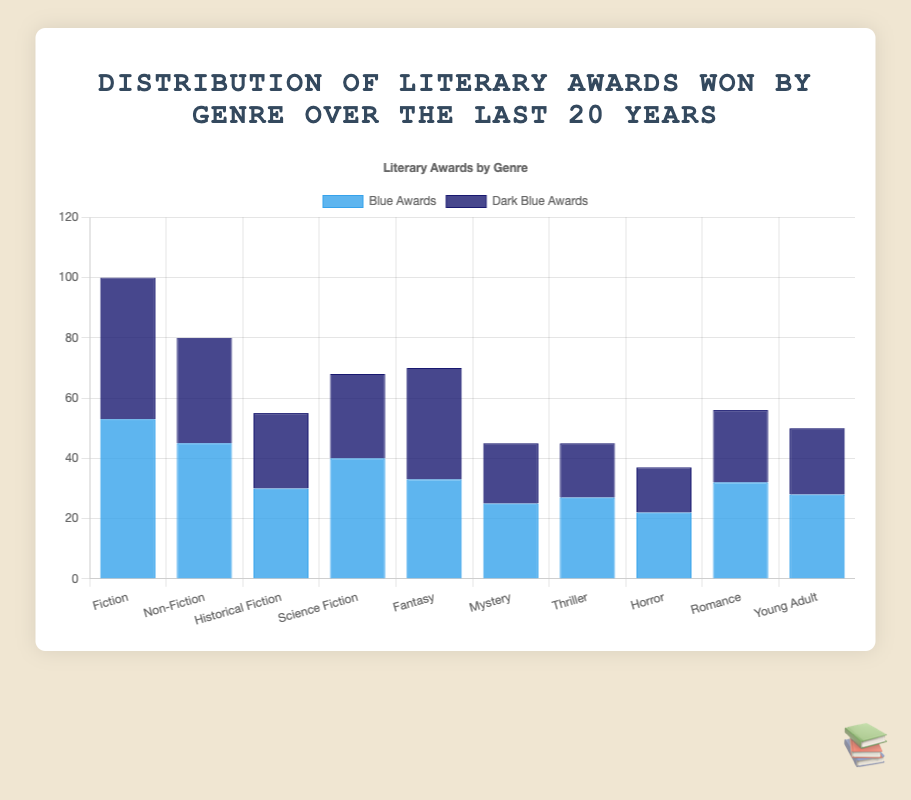Which genre has the highest total number of awards? To find the genre with the highest total number of awards, we need to sum the blue and dark blue awards for each genre and compare. Fiction: 53 + 47 = 100, Non-Fiction: 45 + 35 = 80, Historical Fiction: 30 + 25 = 55, Science Fiction: 40 + 28 = 68, Fantasy: 33 + 37 = 70, Mystery: 25 + 20 = 45, Thriller: 27 + 18 = 45, Horror: 22 + 15 = 37, Romance: 32 + 24 = 56, Young Adult: 28 + 22 = 50. Fiction has the highest number of awards with 100.
Answer: Fiction Which genre has the most dark blue awards? To identify the genre with the most dark blue awards, we need to look for the highest dark blue bar in the chart. The counts of dark blue awards for each genre are: Fiction: 47, Non-Fiction: 35, Historical Fiction: 25, Science Fiction: 28, Fantasy: 37, Mystery: 20, Thriller: 18, Horror: 15, Romance: 24, Young Adult: 22. Fantasy has the most dark blue awards with 37.
Answer: Fantasy How many awards in total have Mystery and Thriller genres won? To find the total awards for Mystery and Thriller, we sum the blue and dark blue awards for both genres. Mystery: 25 + 20 = 45, Thriller: 27 + 18 = 45. Thus, the total is 45 + 45 = 90.
Answer: 90 What is the ratio of blue awards to dark blue awards in the Science Fiction genre? For Science Fiction, the number of blue awards is 40 and dark blue awards is 28. Thus, the ratio is 40:28. To simplify, divide both numbers by 4, resulting in a 10:7 ratio.
Answer: 10:7 Which genres have an equal or almost equal number of blue and dark blue awards? Compare the blue and dark blue awards for each genre. The pairs that are close or equal are: Fiction (53, 47), Historical Fiction (30, 25), Science Fiction (40, 28), Fantasy (33, 37), Mystery (25, 20), Romance (32, 24), Young Adult (28, 22). The genre pairs are Fiction and Fantasy.
Answer: Fiction, Fantasy If we combine the total awards for genres Fiction and Fantasy, what is the combined number? First, we calculate the total awards for each genre separately: Fiction: 53 + 47 = 100, Fantasy: 33 + 37 = 70. The sum of their totals is 100 + 70 = 170.
Answer: 170 Which genre has fewer blue awards compared to its dark blue awards? Comparing the blue and dark blue awards for each genre, only Fantasy (blue: 33, dark blue: 37) has fewer blue awards than dark blue awards.
Answer: Fantasy 